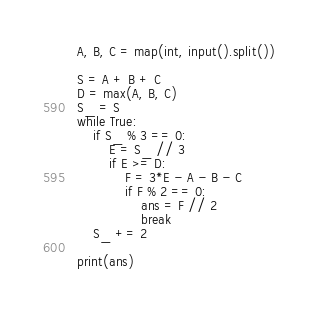<code> <loc_0><loc_0><loc_500><loc_500><_Python_>A, B, C = map(int, input().split())

S = A + B + C
D = max(A, B, C)
S_ = S
while True:
    if S_ % 3 == 0:
        E = S_ // 3
        if E >= D:
            F = 3*E - A - B - C
            if F % 2 == 0:
                ans = F // 2
                break
    S_ += 2

print(ans)</code> 